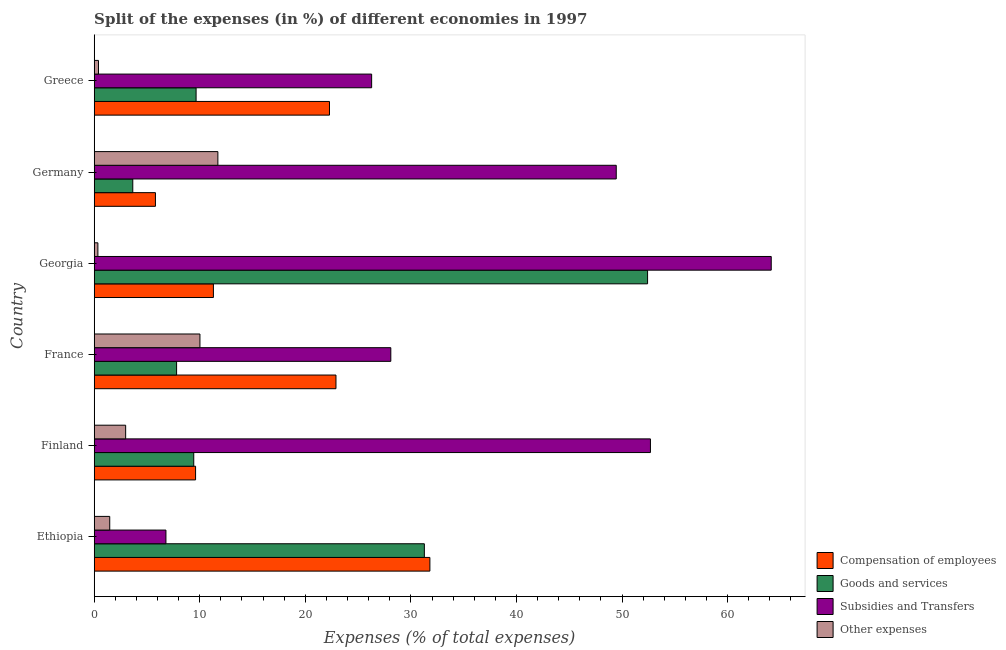How many groups of bars are there?
Your answer should be very brief. 6. What is the label of the 3rd group of bars from the top?
Your response must be concise. Georgia. In how many cases, is the number of bars for a given country not equal to the number of legend labels?
Provide a short and direct response. 0. What is the percentage of amount spent on compensation of employees in Georgia?
Provide a short and direct response. 11.29. Across all countries, what is the maximum percentage of amount spent on compensation of employees?
Make the answer very short. 31.8. Across all countries, what is the minimum percentage of amount spent on goods and services?
Your answer should be very brief. 3.65. In which country was the percentage of amount spent on goods and services maximum?
Keep it short and to the point. Georgia. In which country was the percentage of amount spent on subsidies minimum?
Offer a very short reply. Ethiopia. What is the total percentage of amount spent on other expenses in the graph?
Offer a terse response. 26.94. What is the difference between the percentage of amount spent on compensation of employees in Ethiopia and that in Greece?
Offer a very short reply. 9.51. What is the difference between the percentage of amount spent on compensation of employees in Ethiopia and the percentage of amount spent on other expenses in Greece?
Give a very brief answer. 31.39. What is the average percentage of amount spent on compensation of employees per country?
Your response must be concise. 17.28. What is the difference between the percentage of amount spent on other expenses and percentage of amount spent on goods and services in Georgia?
Ensure brevity in your answer.  -52.07. In how many countries, is the percentage of amount spent on subsidies greater than 38 %?
Give a very brief answer. 3. What is the ratio of the percentage of amount spent on other expenses in Finland to that in Germany?
Provide a short and direct response. 0.25. What is the difference between the highest and the second highest percentage of amount spent on compensation of employees?
Provide a short and direct response. 8.9. What is the difference between the highest and the lowest percentage of amount spent on other expenses?
Keep it short and to the point. 11.37. In how many countries, is the percentage of amount spent on other expenses greater than the average percentage of amount spent on other expenses taken over all countries?
Give a very brief answer. 2. Is the sum of the percentage of amount spent on compensation of employees in Finland and Germany greater than the maximum percentage of amount spent on subsidies across all countries?
Give a very brief answer. No. What does the 1st bar from the top in Germany represents?
Make the answer very short. Other expenses. What does the 1st bar from the bottom in Finland represents?
Provide a succinct answer. Compensation of employees. Are all the bars in the graph horizontal?
Your answer should be very brief. Yes. What is the difference between two consecutive major ticks on the X-axis?
Give a very brief answer. 10. Are the values on the major ticks of X-axis written in scientific E-notation?
Your answer should be compact. No. Does the graph contain any zero values?
Offer a very short reply. No. How are the legend labels stacked?
Provide a short and direct response. Vertical. What is the title of the graph?
Ensure brevity in your answer.  Split of the expenses (in %) of different economies in 1997. Does "United Kingdom" appear as one of the legend labels in the graph?
Offer a very short reply. No. What is the label or title of the X-axis?
Give a very brief answer. Expenses (% of total expenses). What is the Expenses (% of total expenses) of Compensation of employees in Ethiopia?
Offer a terse response. 31.8. What is the Expenses (% of total expenses) of Goods and services in Ethiopia?
Your answer should be compact. 31.27. What is the Expenses (% of total expenses) in Subsidies and Transfers in Ethiopia?
Make the answer very short. 6.8. What is the Expenses (% of total expenses) of Other expenses in Ethiopia?
Keep it short and to the point. 1.47. What is the Expenses (% of total expenses) in Compensation of employees in Finland?
Make the answer very short. 9.6. What is the Expenses (% of total expenses) of Goods and services in Finland?
Your answer should be compact. 9.43. What is the Expenses (% of total expenses) in Subsidies and Transfers in Finland?
Make the answer very short. 52.69. What is the Expenses (% of total expenses) in Other expenses in Finland?
Give a very brief answer. 2.98. What is the Expenses (% of total expenses) of Compensation of employees in France?
Your answer should be compact. 22.9. What is the Expenses (% of total expenses) of Goods and services in France?
Keep it short and to the point. 7.81. What is the Expenses (% of total expenses) in Subsidies and Transfers in France?
Ensure brevity in your answer.  28.1. What is the Expenses (% of total expenses) of Other expenses in France?
Your answer should be very brief. 10.02. What is the Expenses (% of total expenses) of Compensation of employees in Georgia?
Offer a very short reply. 11.29. What is the Expenses (% of total expenses) of Goods and services in Georgia?
Make the answer very short. 52.42. What is the Expenses (% of total expenses) of Subsidies and Transfers in Georgia?
Your response must be concise. 64.13. What is the Expenses (% of total expenses) in Other expenses in Georgia?
Make the answer very short. 0.35. What is the Expenses (% of total expenses) of Compensation of employees in Germany?
Offer a terse response. 5.8. What is the Expenses (% of total expenses) in Goods and services in Germany?
Ensure brevity in your answer.  3.65. What is the Expenses (% of total expenses) of Subsidies and Transfers in Germany?
Your answer should be very brief. 49.45. What is the Expenses (% of total expenses) of Other expenses in Germany?
Your response must be concise. 11.72. What is the Expenses (% of total expenses) of Compensation of employees in Greece?
Provide a succinct answer. 22.29. What is the Expenses (% of total expenses) of Goods and services in Greece?
Offer a terse response. 9.65. What is the Expenses (% of total expenses) in Subsidies and Transfers in Greece?
Offer a terse response. 26.28. What is the Expenses (% of total expenses) of Other expenses in Greece?
Offer a terse response. 0.41. Across all countries, what is the maximum Expenses (% of total expenses) of Compensation of employees?
Your answer should be compact. 31.8. Across all countries, what is the maximum Expenses (% of total expenses) of Goods and services?
Keep it short and to the point. 52.42. Across all countries, what is the maximum Expenses (% of total expenses) of Subsidies and Transfers?
Provide a succinct answer. 64.13. Across all countries, what is the maximum Expenses (% of total expenses) of Other expenses?
Ensure brevity in your answer.  11.72. Across all countries, what is the minimum Expenses (% of total expenses) of Compensation of employees?
Your answer should be compact. 5.8. Across all countries, what is the minimum Expenses (% of total expenses) in Goods and services?
Your answer should be very brief. 3.65. Across all countries, what is the minimum Expenses (% of total expenses) of Subsidies and Transfers?
Offer a very short reply. 6.8. Across all countries, what is the minimum Expenses (% of total expenses) in Other expenses?
Keep it short and to the point. 0.35. What is the total Expenses (% of total expenses) of Compensation of employees in the graph?
Give a very brief answer. 103.69. What is the total Expenses (% of total expenses) of Goods and services in the graph?
Your response must be concise. 114.24. What is the total Expenses (% of total expenses) in Subsidies and Transfers in the graph?
Provide a succinct answer. 227.45. What is the total Expenses (% of total expenses) in Other expenses in the graph?
Your answer should be very brief. 26.94. What is the difference between the Expenses (% of total expenses) in Compensation of employees in Ethiopia and that in Finland?
Offer a terse response. 22.2. What is the difference between the Expenses (% of total expenses) in Goods and services in Ethiopia and that in Finland?
Your answer should be compact. 21.84. What is the difference between the Expenses (% of total expenses) of Subsidies and Transfers in Ethiopia and that in Finland?
Provide a succinct answer. -45.9. What is the difference between the Expenses (% of total expenses) in Other expenses in Ethiopia and that in Finland?
Make the answer very short. -1.51. What is the difference between the Expenses (% of total expenses) of Compensation of employees in Ethiopia and that in France?
Provide a succinct answer. 8.9. What is the difference between the Expenses (% of total expenses) of Goods and services in Ethiopia and that in France?
Give a very brief answer. 23.47. What is the difference between the Expenses (% of total expenses) of Subsidies and Transfers in Ethiopia and that in France?
Offer a terse response. -21.3. What is the difference between the Expenses (% of total expenses) in Other expenses in Ethiopia and that in France?
Provide a short and direct response. -8.54. What is the difference between the Expenses (% of total expenses) in Compensation of employees in Ethiopia and that in Georgia?
Your answer should be compact. 20.51. What is the difference between the Expenses (% of total expenses) in Goods and services in Ethiopia and that in Georgia?
Your answer should be very brief. -21.14. What is the difference between the Expenses (% of total expenses) in Subsidies and Transfers in Ethiopia and that in Georgia?
Provide a short and direct response. -57.34. What is the difference between the Expenses (% of total expenses) in Other expenses in Ethiopia and that in Georgia?
Your response must be concise. 1.12. What is the difference between the Expenses (% of total expenses) of Compensation of employees in Ethiopia and that in Germany?
Your response must be concise. 26. What is the difference between the Expenses (% of total expenses) in Goods and services in Ethiopia and that in Germany?
Provide a succinct answer. 27.62. What is the difference between the Expenses (% of total expenses) of Subsidies and Transfers in Ethiopia and that in Germany?
Your response must be concise. -42.66. What is the difference between the Expenses (% of total expenses) of Other expenses in Ethiopia and that in Germany?
Your response must be concise. -10.24. What is the difference between the Expenses (% of total expenses) of Compensation of employees in Ethiopia and that in Greece?
Make the answer very short. 9.51. What is the difference between the Expenses (% of total expenses) in Goods and services in Ethiopia and that in Greece?
Provide a short and direct response. 21.62. What is the difference between the Expenses (% of total expenses) in Subsidies and Transfers in Ethiopia and that in Greece?
Keep it short and to the point. -19.48. What is the difference between the Expenses (% of total expenses) in Other expenses in Ethiopia and that in Greece?
Provide a short and direct response. 1.07. What is the difference between the Expenses (% of total expenses) of Compensation of employees in Finland and that in France?
Make the answer very short. -13.3. What is the difference between the Expenses (% of total expenses) in Goods and services in Finland and that in France?
Keep it short and to the point. 1.62. What is the difference between the Expenses (% of total expenses) of Subsidies and Transfers in Finland and that in France?
Ensure brevity in your answer.  24.59. What is the difference between the Expenses (% of total expenses) of Other expenses in Finland and that in France?
Provide a short and direct response. -7.04. What is the difference between the Expenses (% of total expenses) in Compensation of employees in Finland and that in Georgia?
Keep it short and to the point. -1.69. What is the difference between the Expenses (% of total expenses) of Goods and services in Finland and that in Georgia?
Keep it short and to the point. -42.99. What is the difference between the Expenses (% of total expenses) in Subsidies and Transfers in Finland and that in Georgia?
Offer a terse response. -11.44. What is the difference between the Expenses (% of total expenses) in Other expenses in Finland and that in Georgia?
Your response must be concise. 2.63. What is the difference between the Expenses (% of total expenses) of Compensation of employees in Finland and that in Germany?
Your answer should be compact. 3.8. What is the difference between the Expenses (% of total expenses) of Goods and services in Finland and that in Germany?
Keep it short and to the point. 5.78. What is the difference between the Expenses (% of total expenses) in Subsidies and Transfers in Finland and that in Germany?
Your response must be concise. 3.24. What is the difference between the Expenses (% of total expenses) of Other expenses in Finland and that in Germany?
Provide a succinct answer. -8.74. What is the difference between the Expenses (% of total expenses) of Compensation of employees in Finland and that in Greece?
Your answer should be compact. -12.68. What is the difference between the Expenses (% of total expenses) of Goods and services in Finland and that in Greece?
Offer a very short reply. -0.22. What is the difference between the Expenses (% of total expenses) in Subsidies and Transfers in Finland and that in Greece?
Provide a short and direct response. 26.41. What is the difference between the Expenses (% of total expenses) of Other expenses in Finland and that in Greece?
Your response must be concise. 2.57. What is the difference between the Expenses (% of total expenses) in Compensation of employees in France and that in Georgia?
Keep it short and to the point. 11.61. What is the difference between the Expenses (% of total expenses) in Goods and services in France and that in Georgia?
Offer a terse response. -44.61. What is the difference between the Expenses (% of total expenses) in Subsidies and Transfers in France and that in Georgia?
Your response must be concise. -36.04. What is the difference between the Expenses (% of total expenses) of Other expenses in France and that in Georgia?
Your response must be concise. 9.67. What is the difference between the Expenses (% of total expenses) in Compensation of employees in France and that in Germany?
Offer a terse response. 17.1. What is the difference between the Expenses (% of total expenses) of Goods and services in France and that in Germany?
Offer a very short reply. 4.15. What is the difference between the Expenses (% of total expenses) in Subsidies and Transfers in France and that in Germany?
Your response must be concise. -21.35. What is the difference between the Expenses (% of total expenses) of Other expenses in France and that in Germany?
Provide a succinct answer. -1.7. What is the difference between the Expenses (% of total expenses) of Compensation of employees in France and that in Greece?
Offer a terse response. 0.61. What is the difference between the Expenses (% of total expenses) in Goods and services in France and that in Greece?
Your answer should be compact. -1.85. What is the difference between the Expenses (% of total expenses) of Subsidies and Transfers in France and that in Greece?
Offer a very short reply. 1.82. What is the difference between the Expenses (% of total expenses) in Other expenses in France and that in Greece?
Ensure brevity in your answer.  9.61. What is the difference between the Expenses (% of total expenses) of Compensation of employees in Georgia and that in Germany?
Provide a succinct answer. 5.49. What is the difference between the Expenses (% of total expenses) in Goods and services in Georgia and that in Germany?
Make the answer very short. 48.77. What is the difference between the Expenses (% of total expenses) of Subsidies and Transfers in Georgia and that in Germany?
Your answer should be compact. 14.68. What is the difference between the Expenses (% of total expenses) of Other expenses in Georgia and that in Germany?
Provide a short and direct response. -11.37. What is the difference between the Expenses (% of total expenses) in Compensation of employees in Georgia and that in Greece?
Your answer should be compact. -11. What is the difference between the Expenses (% of total expenses) in Goods and services in Georgia and that in Greece?
Offer a terse response. 42.77. What is the difference between the Expenses (% of total expenses) of Subsidies and Transfers in Georgia and that in Greece?
Offer a very short reply. 37.85. What is the difference between the Expenses (% of total expenses) in Other expenses in Georgia and that in Greece?
Provide a short and direct response. -0.06. What is the difference between the Expenses (% of total expenses) of Compensation of employees in Germany and that in Greece?
Keep it short and to the point. -16.49. What is the difference between the Expenses (% of total expenses) of Goods and services in Germany and that in Greece?
Offer a very short reply. -6. What is the difference between the Expenses (% of total expenses) in Subsidies and Transfers in Germany and that in Greece?
Ensure brevity in your answer.  23.17. What is the difference between the Expenses (% of total expenses) in Other expenses in Germany and that in Greece?
Your answer should be very brief. 11.31. What is the difference between the Expenses (% of total expenses) in Compensation of employees in Ethiopia and the Expenses (% of total expenses) in Goods and services in Finland?
Provide a succinct answer. 22.37. What is the difference between the Expenses (% of total expenses) of Compensation of employees in Ethiopia and the Expenses (% of total expenses) of Subsidies and Transfers in Finland?
Your answer should be very brief. -20.89. What is the difference between the Expenses (% of total expenses) in Compensation of employees in Ethiopia and the Expenses (% of total expenses) in Other expenses in Finland?
Give a very brief answer. 28.82. What is the difference between the Expenses (% of total expenses) of Goods and services in Ethiopia and the Expenses (% of total expenses) of Subsidies and Transfers in Finland?
Your answer should be very brief. -21.42. What is the difference between the Expenses (% of total expenses) of Goods and services in Ethiopia and the Expenses (% of total expenses) of Other expenses in Finland?
Offer a terse response. 28.29. What is the difference between the Expenses (% of total expenses) in Subsidies and Transfers in Ethiopia and the Expenses (% of total expenses) in Other expenses in Finland?
Offer a very short reply. 3.82. What is the difference between the Expenses (% of total expenses) in Compensation of employees in Ethiopia and the Expenses (% of total expenses) in Goods and services in France?
Offer a very short reply. 23.99. What is the difference between the Expenses (% of total expenses) in Compensation of employees in Ethiopia and the Expenses (% of total expenses) in Subsidies and Transfers in France?
Your answer should be very brief. 3.7. What is the difference between the Expenses (% of total expenses) in Compensation of employees in Ethiopia and the Expenses (% of total expenses) in Other expenses in France?
Your response must be concise. 21.78. What is the difference between the Expenses (% of total expenses) of Goods and services in Ethiopia and the Expenses (% of total expenses) of Subsidies and Transfers in France?
Keep it short and to the point. 3.18. What is the difference between the Expenses (% of total expenses) of Goods and services in Ethiopia and the Expenses (% of total expenses) of Other expenses in France?
Provide a short and direct response. 21.26. What is the difference between the Expenses (% of total expenses) in Subsidies and Transfers in Ethiopia and the Expenses (% of total expenses) in Other expenses in France?
Make the answer very short. -3.22. What is the difference between the Expenses (% of total expenses) of Compensation of employees in Ethiopia and the Expenses (% of total expenses) of Goods and services in Georgia?
Give a very brief answer. -20.62. What is the difference between the Expenses (% of total expenses) in Compensation of employees in Ethiopia and the Expenses (% of total expenses) in Subsidies and Transfers in Georgia?
Offer a terse response. -32.33. What is the difference between the Expenses (% of total expenses) in Compensation of employees in Ethiopia and the Expenses (% of total expenses) in Other expenses in Georgia?
Ensure brevity in your answer.  31.45. What is the difference between the Expenses (% of total expenses) in Goods and services in Ethiopia and the Expenses (% of total expenses) in Subsidies and Transfers in Georgia?
Keep it short and to the point. -32.86. What is the difference between the Expenses (% of total expenses) in Goods and services in Ethiopia and the Expenses (% of total expenses) in Other expenses in Georgia?
Provide a succinct answer. 30.92. What is the difference between the Expenses (% of total expenses) in Subsidies and Transfers in Ethiopia and the Expenses (% of total expenses) in Other expenses in Georgia?
Provide a succinct answer. 6.45. What is the difference between the Expenses (% of total expenses) of Compensation of employees in Ethiopia and the Expenses (% of total expenses) of Goods and services in Germany?
Your response must be concise. 28.14. What is the difference between the Expenses (% of total expenses) in Compensation of employees in Ethiopia and the Expenses (% of total expenses) in Subsidies and Transfers in Germany?
Offer a terse response. -17.65. What is the difference between the Expenses (% of total expenses) of Compensation of employees in Ethiopia and the Expenses (% of total expenses) of Other expenses in Germany?
Keep it short and to the point. 20.08. What is the difference between the Expenses (% of total expenses) of Goods and services in Ethiopia and the Expenses (% of total expenses) of Subsidies and Transfers in Germany?
Offer a terse response. -18.18. What is the difference between the Expenses (% of total expenses) in Goods and services in Ethiopia and the Expenses (% of total expenses) in Other expenses in Germany?
Offer a very short reply. 19.56. What is the difference between the Expenses (% of total expenses) in Subsidies and Transfers in Ethiopia and the Expenses (% of total expenses) in Other expenses in Germany?
Your answer should be compact. -4.92. What is the difference between the Expenses (% of total expenses) of Compensation of employees in Ethiopia and the Expenses (% of total expenses) of Goods and services in Greece?
Your response must be concise. 22.15. What is the difference between the Expenses (% of total expenses) of Compensation of employees in Ethiopia and the Expenses (% of total expenses) of Subsidies and Transfers in Greece?
Provide a succinct answer. 5.52. What is the difference between the Expenses (% of total expenses) in Compensation of employees in Ethiopia and the Expenses (% of total expenses) in Other expenses in Greece?
Your answer should be very brief. 31.39. What is the difference between the Expenses (% of total expenses) in Goods and services in Ethiopia and the Expenses (% of total expenses) in Subsidies and Transfers in Greece?
Offer a terse response. 4.99. What is the difference between the Expenses (% of total expenses) in Goods and services in Ethiopia and the Expenses (% of total expenses) in Other expenses in Greece?
Make the answer very short. 30.87. What is the difference between the Expenses (% of total expenses) of Subsidies and Transfers in Ethiopia and the Expenses (% of total expenses) of Other expenses in Greece?
Offer a very short reply. 6.39. What is the difference between the Expenses (% of total expenses) of Compensation of employees in Finland and the Expenses (% of total expenses) of Goods and services in France?
Your answer should be compact. 1.8. What is the difference between the Expenses (% of total expenses) in Compensation of employees in Finland and the Expenses (% of total expenses) in Subsidies and Transfers in France?
Ensure brevity in your answer.  -18.49. What is the difference between the Expenses (% of total expenses) in Compensation of employees in Finland and the Expenses (% of total expenses) in Other expenses in France?
Provide a succinct answer. -0.41. What is the difference between the Expenses (% of total expenses) in Goods and services in Finland and the Expenses (% of total expenses) in Subsidies and Transfers in France?
Keep it short and to the point. -18.67. What is the difference between the Expenses (% of total expenses) in Goods and services in Finland and the Expenses (% of total expenses) in Other expenses in France?
Give a very brief answer. -0.59. What is the difference between the Expenses (% of total expenses) in Subsidies and Transfers in Finland and the Expenses (% of total expenses) in Other expenses in France?
Keep it short and to the point. 42.68. What is the difference between the Expenses (% of total expenses) of Compensation of employees in Finland and the Expenses (% of total expenses) of Goods and services in Georgia?
Give a very brief answer. -42.82. What is the difference between the Expenses (% of total expenses) in Compensation of employees in Finland and the Expenses (% of total expenses) in Subsidies and Transfers in Georgia?
Your response must be concise. -54.53. What is the difference between the Expenses (% of total expenses) of Compensation of employees in Finland and the Expenses (% of total expenses) of Other expenses in Georgia?
Give a very brief answer. 9.25. What is the difference between the Expenses (% of total expenses) in Goods and services in Finland and the Expenses (% of total expenses) in Subsidies and Transfers in Georgia?
Your answer should be very brief. -54.7. What is the difference between the Expenses (% of total expenses) of Goods and services in Finland and the Expenses (% of total expenses) of Other expenses in Georgia?
Your response must be concise. 9.08. What is the difference between the Expenses (% of total expenses) in Subsidies and Transfers in Finland and the Expenses (% of total expenses) in Other expenses in Georgia?
Keep it short and to the point. 52.34. What is the difference between the Expenses (% of total expenses) in Compensation of employees in Finland and the Expenses (% of total expenses) in Goods and services in Germany?
Your response must be concise. 5.95. What is the difference between the Expenses (% of total expenses) in Compensation of employees in Finland and the Expenses (% of total expenses) in Subsidies and Transfers in Germany?
Offer a terse response. -39.85. What is the difference between the Expenses (% of total expenses) of Compensation of employees in Finland and the Expenses (% of total expenses) of Other expenses in Germany?
Ensure brevity in your answer.  -2.11. What is the difference between the Expenses (% of total expenses) of Goods and services in Finland and the Expenses (% of total expenses) of Subsidies and Transfers in Germany?
Offer a very short reply. -40.02. What is the difference between the Expenses (% of total expenses) of Goods and services in Finland and the Expenses (% of total expenses) of Other expenses in Germany?
Give a very brief answer. -2.29. What is the difference between the Expenses (% of total expenses) in Subsidies and Transfers in Finland and the Expenses (% of total expenses) in Other expenses in Germany?
Keep it short and to the point. 40.98. What is the difference between the Expenses (% of total expenses) of Compensation of employees in Finland and the Expenses (% of total expenses) of Goods and services in Greece?
Ensure brevity in your answer.  -0.05. What is the difference between the Expenses (% of total expenses) of Compensation of employees in Finland and the Expenses (% of total expenses) of Subsidies and Transfers in Greece?
Provide a succinct answer. -16.68. What is the difference between the Expenses (% of total expenses) of Compensation of employees in Finland and the Expenses (% of total expenses) of Other expenses in Greece?
Provide a succinct answer. 9.2. What is the difference between the Expenses (% of total expenses) of Goods and services in Finland and the Expenses (% of total expenses) of Subsidies and Transfers in Greece?
Ensure brevity in your answer.  -16.85. What is the difference between the Expenses (% of total expenses) in Goods and services in Finland and the Expenses (% of total expenses) in Other expenses in Greece?
Your response must be concise. 9.02. What is the difference between the Expenses (% of total expenses) of Subsidies and Transfers in Finland and the Expenses (% of total expenses) of Other expenses in Greece?
Make the answer very short. 52.29. What is the difference between the Expenses (% of total expenses) in Compensation of employees in France and the Expenses (% of total expenses) in Goods and services in Georgia?
Ensure brevity in your answer.  -29.52. What is the difference between the Expenses (% of total expenses) in Compensation of employees in France and the Expenses (% of total expenses) in Subsidies and Transfers in Georgia?
Offer a very short reply. -41.23. What is the difference between the Expenses (% of total expenses) of Compensation of employees in France and the Expenses (% of total expenses) of Other expenses in Georgia?
Make the answer very short. 22.55. What is the difference between the Expenses (% of total expenses) of Goods and services in France and the Expenses (% of total expenses) of Subsidies and Transfers in Georgia?
Give a very brief answer. -56.33. What is the difference between the Expenses (% of total expenses) in Goods and services in France and the Expenses (% of total expenses) in Other expenses in Georgia?
Provide a succinct answer. 7.46. What is the difference between the Expenses (% of total expenses) of Subsidies and Transfers in France and the Expenses (% of total expenses) of Other expenses in Georgia?
Provide a succinct answer. 27.75. What is the difference between the Expenses (% of total expenses) of Compensation of employees in France and the Expenses (% of total expenses) of Goods and services in Germany?
Provide a short and direct response. 19.25. What is the difference between the Expenses (% of total expenses) in Compensation of employees in France and the Expenses (% of total expenses) in Subsidies and Transfers in Germany?
Your answer should be very brief. -26.55. What is the difference between the Expenses (% of total expenses) of Compensation of employees in France and the Expenses (% of total expenses) of Other expenses in Germany?
Ensure brevity in your answer.  11.19. What is the difference between the Expenses (% of total expenses) in Goods and services in France and the Expenses (% of total expenses) in Subsidies and Transfers in Germany?
Your response must be concise. -41.65. What is the difference between the Expenses (% of total expenses) in Goods and services in France and the Expenses (% of total expenses) in Other expenses in Germany?
Keep it short and to the point. -3.91. What is the difference between the Expenses (% of total expenses) of Subsidies and Transfers in France and the Expenses (% of total expenses) of Other expenses in Germany?
Your response must be concise. 16.38. What is the difference between the Expenses (% of total expenses) of Compensation of employees in France and the Expenses (% of total expenses) of Goods and services in Greece?
Offer a terse response. 13.25. What is the difference between the Expenses (% of total expenses) of Compensation of employees in France and the Expenses (% of total expenses) of Subsidies and Transfers in Greece?
Make the answer very short. -3.38. What is the difference between the Expenses (% of total expenses) in Compensation of employees in France and the Expenses (% of total expenses) in Other expenses in Greece?
Make the answer very short. 22.5. What is the difference between the Expenses (% of total expenses) in Goods and services in France and the Expenses (% of total expenses) in Subsidies and Transfers in Greece?
Keep it short and to the point. -18.48. What is the difference between the Expenses (% of total expenses) of Goods and services in France and the Expenses (% of total expenses) of Other expenses in Greece?
Your answer should be compact. 7.4. What is the difference between the Expenses (% of total expenses) in Subsidies and Transfers in France and the Expenses (% of total expenses) in Other expenses in Greece?
Ensure brevity in your answer.  27.69. What is the difference between the Expenses (% of total expenses) of Compensation of employees in Georgia and the Expenses (% of total expenses) of Goods and services in Germany?
Your response must be concise. 7.64. What is the difference between the Expenses (% of total expenses) of Compensation of employees in Georgia and the Expenses (% of total expenses) of Subsidies and Transfers in Germany?
Ensure brevity in your answer.  -38.16. What is the difference between the Expenses (% of total expenses) of Compensation of employees in Georgia and the Expenses (% of total expenses) of Other expenses in Germany?
Offer a very short reply. -0.42. What is the difference between the Expenses (% of total expenses) of Goods and services in Georgia and the Expenses (% of total expenses) of Subsidies and Transfers in Germany?
Your response must be concise. 2.97. What is the difference between the Expenses (% of total expenses) of Goods and services in Georgia and the Expenses (% of total expenses) of Other expenses in Germany?
Offer a very short reply. 40.7. What is the difference between the Expenses (% of total expenses) in Subsidies and Transfers in Georgia and the Expenses (% of total expenses) in Other expenses in Germany?
Your answer should be very brief. 52.42. What is the difference between the Expenses (% of total expenses) in Compensation of employees in Georgia and the Expenses (% of total expenses) in Goods and services in Greece?
Provide a succinct answer. 1.64. What is the difference between the Expenses (% of total expenses) in Compensation of employees in Georgia and the Expenses (% of total expenses) in Subsidies and Transfers in Greece?
Your answer should be compact. -14.99. What is the difference between the Expenses (% of total expenses) in Compensation of employees in Georgia and the Expenses (% of total expenses) in Other expenses in Greece?
Offer a very short reply. 10.89. What is the difference between the Expenses (% of total expenses) of Goods and services in Georgia and the Expenses (% of total expenses) of Subsidies and Transfers in Greece?
Offer a very short reply. 26.14. What is the difference between the Expenses (% of total expenses) in Goods and services in Georgia and the Expenses (% of total expenses) in Other expenses in Greece?
Offer a terse response. 52.01. What is the difference between the Expenses (% of total expenses) in Subsidies and Transfers in Georgia and the Expenses (% of total expenses) in Other expenses in Greece?
Offer a very short reply. 63.73. What is the difference between the Expenses (% of total expenses) of Compensation of employees in Germany and the Expenses (% of total expenses) of Goods and services in Greece?
Give a very brief answer. -3.85. What is the difference between the Expenses (% of total expenses) in Compensation of employees in Germany and the Expenses (% of total expenses) in Subsidies and Transfers in Greece?
Your answer should be compact. -20.48. What is the difference between the Expenses (% of total expenses) in Compensation of employees in Germany and the Expenses (% of total expenses) in Other expenses in Greece?
Offer a terse response. 5.4. What is the difference between the Expenses (% of total expenses) of Goods and services in Germany and the Expenses (% of total expenses) of Subsidies and Transfers in Greece?
Offer a terse response. -22.63. What is the difference between the Expenses (% of total expenses) of Goods and services in Germany and the Expenses (% of total expenses) of Other expenses in Greece?
Your answer should be very brief. 3.25. What is the difference between the Expenses (% of total expenses) of Subsidies and Transfers in Germany and the Expenses (% of total expenses) of Other expenses in Greece?
Ensure brevity in your answer.  49.05. What is the average Expenses (% of total expenses) of Compensation of employees per country?
Provide a succinct answer. 17.28. What is the average Expenses (% of total expenses) of Goods and services per country?
Give a very brief answer. 19.04. What is the average Expenses (% of total expenses) in Subsidies and Transfers per country?
Your response must be concise. 37.91. What is the average Expenses (% of total expenses) in Other expenses per country?
Make the answer very short. 4.49. What is the difference between the Expenses (% of total expenses) in Compensation of employees and Expenses (% of total expenses) in Goods and services in Ethiopia?
Your answer should be very brief. 0.52. What is the difference between the Expenses (% of total expenses) of Compensation of employees and Expenses (% of total expenses) of Subsidies and Transfers in Ethiopia?
Give a very brief answer. 25. What is the difference between the Expenses (% of total expenses) in Compensation of employees and Expenses (% of total expenses) in Other expenses in Ethiopia?
Give a very brief answer. 30.33. What is the difference between the Expenses (% of total expenses) in Goods and services and Expenses (% of total expenses) in Subsidies and Transfers in Ethiopia?
Your response must be concise. 24.48. What is the difference between the Expenses (% of total expenses) in Goods and services and Expenses (% of total expenses) in Other expenses in Ethiopia?
Give a very brief answer. 29.8. What is the difference between the Expenses (% of total expenses) of Subsidies and Transfers and Expenses (% of total expenses) of Other expenses in Ethiopia?
Your answer should be compact. 5.33. What is the difference between the Expenses (% of total expenses) of Compensation of employees and Expenses (% of total expenses) of Goods and services in Finland?
Ensure brevity in your answer.  0.17. What is the difference between the Expenses (% of total expenses) in Compensation of employees and Expenses (% of total expenses) in Subsidies and Transfers in Finland?
Ensure brevity in your answer.  -43.09. What is the difference between the Expenses (% of total expenses) in Compensation of employees and Expenses (% of total expenses) in Other expenses in Finland?
Offer a very short reply. 6.62. What is the difference between the Expenses (% of total expenses) in Goods and services and Expenses (% of total expenses) in Subsidies and Transfers in Finland?
Your response must be concise. -43.26. What is the difference between the Expenses (% of total expenses) in Goods and services and Expenses (% of total expenses) in Other expenses in Finland?
Keep it short and to the point. 6.45. What is the difference between the Expenses (% of total expenses) of Subsidies and Transfers and Expenses (% of total expenses) of Other expenses in Finland?
Provide a succinct answer. 49.71. What is the difference between the Expenses (% of total expenses) of Compensation of employees and Expenses (% of total expenses) of Goods and services in France?
Make the answer very short. 15.1. What is the difference between the Expenses (% of total expenses) of Compensation of employees and Expenses (% of total expenses) of Subsidies and Transfers in France?
Ensure brevity in your answer.  -5.2. What is the difference between the Expenses (% of total expenses) of Compensation of employees and Expenses (% of total expenses) of Other expenses in France?
Provide a succinct answer. 12.89. What is the difference between the Expenses (% of total expenses) in Goods and services and Expenses (% of total expenses) in Subsidies and Transfers in France?
Make the answer very short. -20.29. What is the difference between the Expenses (% of total expenses) in Goods and services and Expenses (% of total expenses) in Other expenses in France?
Provide a succinct answer. -2.21. What is the difference between the Expenses (% of total expenses) in Subsidies and Transfers and Expenses (% of total expenses) in Other expenses in France?
Offer a very short reply. 18.08. What is the difference between the Expenses (% of total expenses) of Compensation of employees and Expenses (% of total expenses) of Goods and services in Georgia?
Give a very brief answer. -41.13. What is the difference between the Expenses (% of total expenses) of Compensation of employees and Expenses (% of total expenses) of Subsidies and Transfers in Georgia?
Make the answer very short. -52.84. What is the difference between the Expenses (% of total expenses) in Compensation of employees and Expenses (% of total expenses) in Other expenses in Georgia?
Ensure brevity in your answer.  10.94. What is the difference between the Expenses (% of total expenses) in Goods and services and Expenses (% of total expenses) in Subsidies and Transfers in Georgia?
Provide a short and direct response. -11.71. What is the difference between the Expenses (% of total expenses) of Goods and services and Expenses (% of total expenses) of Other expenses in Georgia?
Your response must be concise. 52.07. What is the difference between the Expenses (% of total expenses) in Subsidies and Transfers and Expenses (% of total expenses) in Other expenses in Georgia?
Make the answer very short. 63.78. What is the difference between the Expenses (% of total expenses) in Compensation of employees and Expenses (% of total expenses) in Goods and services in Germany?
Ensure brevity in your answer.  2.15. What is the difference between the Expenses (% of total expenses) of Compensation of employees and Expenses (% of total expenses) of Subsidies and Transfers in Germany?
Your answer should be compact. -43.65. What is the difference between the Expenses (% of total expenses) in Compensation of employees and Expenses (% of total expenses) in Other expenses in Germany?
Give a very brief answer. -5.91. What is the difference between the Expenses (% of total expenses) of Goods and services and Expenses (% of total expenses) of Subsidies and Transfers in Germany?
Keep it short and to the point. -45.8. What is the difference between the Expenses (% of total expenses) of Goods and services and Expenses (% of total expenses) of Other expenses in Germany?
Ensure brevity in your answer.  -8.06. What is the difference between the Expenses (% of total expenses) in Subsidies and Transfers and Expenses (% of total expenses) in Other expenses in Germany?
Offer a terse response. 37.74. What is the difference between the Expenses (% of total expenses) of Compensation of employees and Expenses (% of total expenses) of Goods and services in Greece?
Offer a very short reply. 12.64. What is the difference between the Expenses (% of total expenses) in Compensation of employees and Expenses (% of total expenses) in Subsidies and Transfers in Greece?
Keep it short and to the point. -3.99. What is the difference between the Expenses (% of total expenses) of Compensation of employees and Expenses (% of total expenses) of Other expenses in Greece?
Make the answer very short. 21.88. What is the difference between the Expenses (% of total expenses) of Goods and services and Expenses (% of total expenses) of Subsidies and Transfers in Greece?
Offer a very short reply. -16.63. What is the difference between the Expenses (% of total expenses) of Goods and services and Expenses (% of total expenses) of Other expenses in Greece?
Keep it short and to the point. 9.25. What is the difference between the Expenses (% of total expenses) of Subsidies and Transfers and Expenses (% of total expenses) of Other expenses in Greece?
Make the answer very short. 25.88. What is the ratio of the Expenses (% of total expenses) of Compensation of employees in Ethiopia to that in Finland?
Your answer should be very brief. 3.31. What is the ratio of the Expenses (% of total expenses) of Goods and services in Ethiopia to that in Finland?
Make the answer very short. 3.32. What is the ratio of the Expenses (% of total expenses) of Subsidies and Transfers in Ethiopia to that in Finland?
Provide a short and direct response. 0.13. What is the ratio of the Expenses (% of total expenses) of Other expenses in Ethiopia to that in Finland?
Ensure brevity in your answer.  0.49. What is the ratio of the Expenses (% of total expenses) of Compensation of employees in Ethiopia to that in France?
Offer a very short reply. 1.39. What is the ratio of the Expenses (% of total expenses) in Goods and services in Ethiopia to that in France?
Give a very brief answer. 4.01. What is the ratio of the Expenses (% of total expenses) of Subsidies and Transfers in Ethiopia to that in France?
Provide a short and direct response. 0.24. What is the ratio of the Expenses (% of total expenses) in Other expenses in Ethiopia to that in France?
Keep it short and to the point. 0.15. What is the ratio of the Expenses (% of total expenses) in Compensation of employees in Ethiopia to that in Georgia?
Ensure brevity in your answer.  2.82. What is the ratio of the Expenses (% of total expenses) in Goods and services in Ethiopia to that in Georgia?
Offer a very short reply. 0.6. What is the ratio of the Expenses (% of total expenses) of Subsidies and Transfers in Ethiopia to that in Georgia?
Your answer should be very brief. 0.11. What is the ratio of the Expenses (% of total expenses) in Other expenses in Ethiopia to that in Georgia?
Your answer should be very brief. 4.2. What is the ratio of the Expenses (% of total expenses) of Compensation of employees in Ethiopia to that in Germany?
Your answer should be very brief. 5.48. What is the ratio of the Expenses (% of total expenses) in Goods and services in Ethiopia to that in Germany?
Ensure brevity in your answer.  8.56. What is the ratio of the Expenses (% of total expenses) in Subsidies and Transfers in Ethiopia to that in Germany?
Your answer should be compact. 0.14. What is the ratio of the Expenses (% of total expenses) in Other expenses in Ethiopia to that in Germany?
Give a very brief answer. 0.13. What is the ratio of the Expenses (% of total expenses) in Compensation of employees in Ethiopia to that in Greece?
Ensure brevity in your answer.  1.43. What is the ratio of the Expenses (% of total expenses) of Goods and services in Ethiopia to that in Greece?
Ensure brevity in your answer.  3.24. What is the ratio of the Expenses (% of total expenses) of Subsidies and Transfers in Ethiopia to that in Greece?
Give a very brief answer. 0.26. What is the ratio of the Expenses (% of total expenses) of Other expenses in Ethiopia to that in Greece?
Provide a succinct answer. 3.62. What is the ratio of the Expenses (% of total expenses) in Compensation of employees in Finland to that in France?
Provide a short and direct response. 0.42. What is the ratio of the Expenses (% of total expenses) in Goods and services in Finland to that in France?
Your answer should be compact. 1.21. What is the ratio of the Expenses (% of total expenses) in Subsidies and Transfers in Finland to that in France?
Provide a succinct answer. 1.88. What is the ratio of the Expenses (% of total expenses) of Other expenses in Finland to that in France?
Provide a short and direct response. 0.3. What is the ratio of the Expenses (% of total expenses) of Compensation of employees in Finland to that in Georgia?
Keep it short and to the point. 0.85. What is the ratio of the Expenses (% of total expenses) in Goods and services in Finland to that in Georgia?
Offer a very short reply. 0.18. What is the ratio of the Expenses (% of total expenses) of Subsidies and Transfers in Finland to that in Georgia?
Give a very brief answer. 0.82. What is the ratio of the Expenses (% of total expenses) of Other expenses in Finland to that in Georgia?
Offer a terse response. 8.51. What is the ratio of the Expenses (% of total expenses) in Compensation of employees in Finland to that in Germany?
Provide a succinct answer. 1.66. What is the ratio of the Expenses (% of total expenses) of Goods and services in Finland to that in Germany?
Offer a very short reply. 2.58. What is the ratio of the Expenses (% of total expenses) of Subsidies and Transfers in Finland to that in Germany?
Offer a very short reply. 1.07. What is the ratio of the Expenses (% of total expenses) in Other expenses in Finland to that in Germany?
Ensure brevity in your answer.  0.25. What is the ratio of the Expenses (% of total expenses) in Compensation of employees in Finland to that in Greece?
Give a very brief answer. 0.43. What is the ratio of the Expenses (% of total expenses) of Goods and services in Finland to that in Greece?
Your answer should be compact. 0.98. What is the ratio of the Expenses (% of total expenses) in Subsidies and Transfers in Finland to that in Greece?
Your response must be concise. 2. What is the ratio of the Expenses (% of total expenses) in Other expenses in Finland to that in Greece?
Offer a very short reply. 7.34. What is the ratio of the Expenses (% of total expenses) of Compensation of employees in France to that in Georgia?
Ensure brevity in your answer.  2.03. What is the ratio of the Expenses (% of total expenses) in Goods and services in France to that in Georgia?
Your response must be concise. 0.15. What is the ratio of the Expenses (% of total expenses) in Subsidies and Transfers in France to that in Georgia?
Offer a terse response. 0.44. What is the ratio of the Expenses (% of total expenses) in Other expenses in France to that in Georgia?
Offer a terse response. 28.6. What is the ratio of the Expenses (% of total expenses) in Compensation of employees in France to that in Germany?
Your answer should be very brief. 3.95. What is the ratio of the Expenses (% of total expenses) of Goods and services in France to that in Germany?
Offer a terse response. 2.14. What is the ratio of the Expenses (% of total expenses) in Subsidies and Transfers in France to that in Germany?
Provide a succinct answer. 0.57. What is the ratio of the Expenses (% of total expenses) of Other expenses in France to that in Germany?
Your response must be concise. 0.85. What is the ratio of the Expenses (% of total expenses) of Compensation of employees in France to that in Greece?
Provide a short and direct response. 1.03. What is the ratio of the Expenses (% of total expenses) in Goods and services in France to that in Greece?
Offer a very short reply. 0.81. What is the ratio of the Expenses (% of total expenses) in Subsidies and Transfers in France to that in Greece?
Make the answer very short. 1.07. What is the ratio of the Expenses (% of total expenses) of Other expenses in France to that in Greece?
Make the answer very short. 24.67. What is the ratio of the Expenses (% of total expenses) in Compensation of employees in Georgia to that in Germany?
Your response must be concise. 1.95. What is the ratio of the Expenses (% of total expenses) in Goods and services in Georgia to that in Germany?
Keep it short and to the point. 14.34. What is the ratio of the Expenses (% of total expenses) of Subsidies and Transfers in Georgia to that in Germany?
Your response must be concise. 1.3. What is the ratio of the Expenses (% of total expenses) in Other expenses in Georgia to that in Germany?
Your answer should be compact. 0.03. What is the ratio of the Expenses (% of total expenses) in Compensation of employees in Georgia to that in Greece?
Your answer should be compact. 0.51. What is the ratio of the Expenses (% of total expenses) in Goods and services in Georgia to that in Greece?
Give a very brief answer. 5.43. What is the ratio of the Expenses (% of total expenses) in Subsidies and Transfers in Georgia to that in Greece?
Offer a very short reply. 2.44. What is the ratio of the Expenses (% of total expenses) of Other expenses in Georgia to that in Greece?
Offer a very short reply. 0.86. What is the ratio of the Expenses (% of total expenses) in Compensation of employees in Germany to that in Greece?
Provide a short and direct response. 0.26. What is the ratio of the Expenses (% of total expenses) of Goods and services in Germany to that in Greece?
Provide a short and direct response. 0.38. What is the ratio of the Expenses (% of total expenses) in Subsidies and Transfers in Germany to that in Greece?
Offer a terse response. 1.88. What is the ratio of the Expenses (% of total expenses) in Other expenses in Germany to that in Greece?
Give a very brief answer. 28.85. What is the difference between the highest and the second highest Expenses (% of total expenses) in Compensation of employees?
Give a very brief answer. 8.9. What is the difference between the highest and the second highest Expenses (% of total expenses) in Goods and services?
Offer a terse response. 21.14. What is the difference between the highest and the second highest Expenses (% of total expenses) of Subsidies and Transfers?
Your answer should be very brief. 11.44. What is the difference between the highest and the second highest Expenses (% of total expenses) of Other expenses?
Offer a very short reply. 1.7. What is the difference between the highest and the lowest Expenses (% of total expenses) in Compensation of employees?
Offer a terse response. 26. What is the difference between the highest and the lowest Expenses (% of total expenses) of Goods and services?
Offer a very short reply. 48.77. What is the difference between the highest and the lowest Expenses (% of total expenses) of Subsidies and Transfers?
Provide a succinct answer. 57.34. What is the difference between the highest and the lowest Expenses (% of total expenses) of Other expenses?
Offer a terse response. 11.37. 